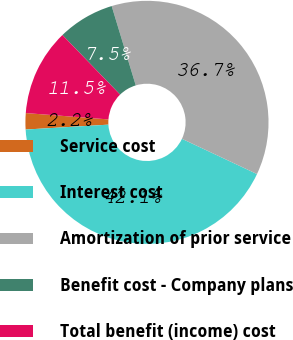Convert chart. <chart><loc_0><loc_0><loc_500><loc_500><pie_chart><fcel>Service cost<fcel>Interest cost<fcel>Amortization of prior service<fcel>Benefit cost - Company plans<fcel>Total benefit (income) cost<nl><fcel>2.16%<fcel>42.07%<fcel>36.68%<fcel>7.55%<fcel>11.54%<nl></chart> 